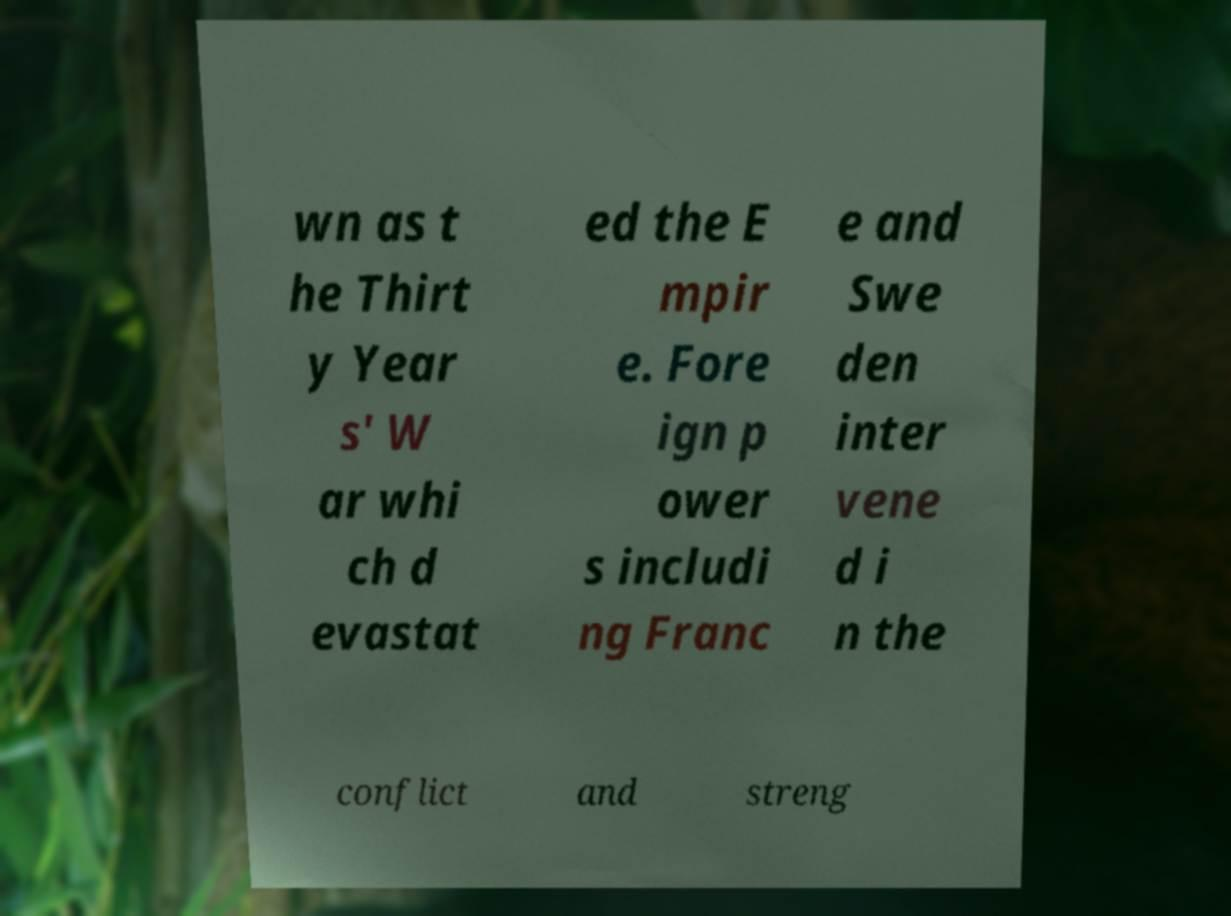Please identify and transcribe the text found in this image. wn as t he Thirt y Year s' W ar whi ch d evastat ed the E mpir e. Fore ign p ower s includi ng Franc e and Swe den inter vene d i n the conflict and streng 